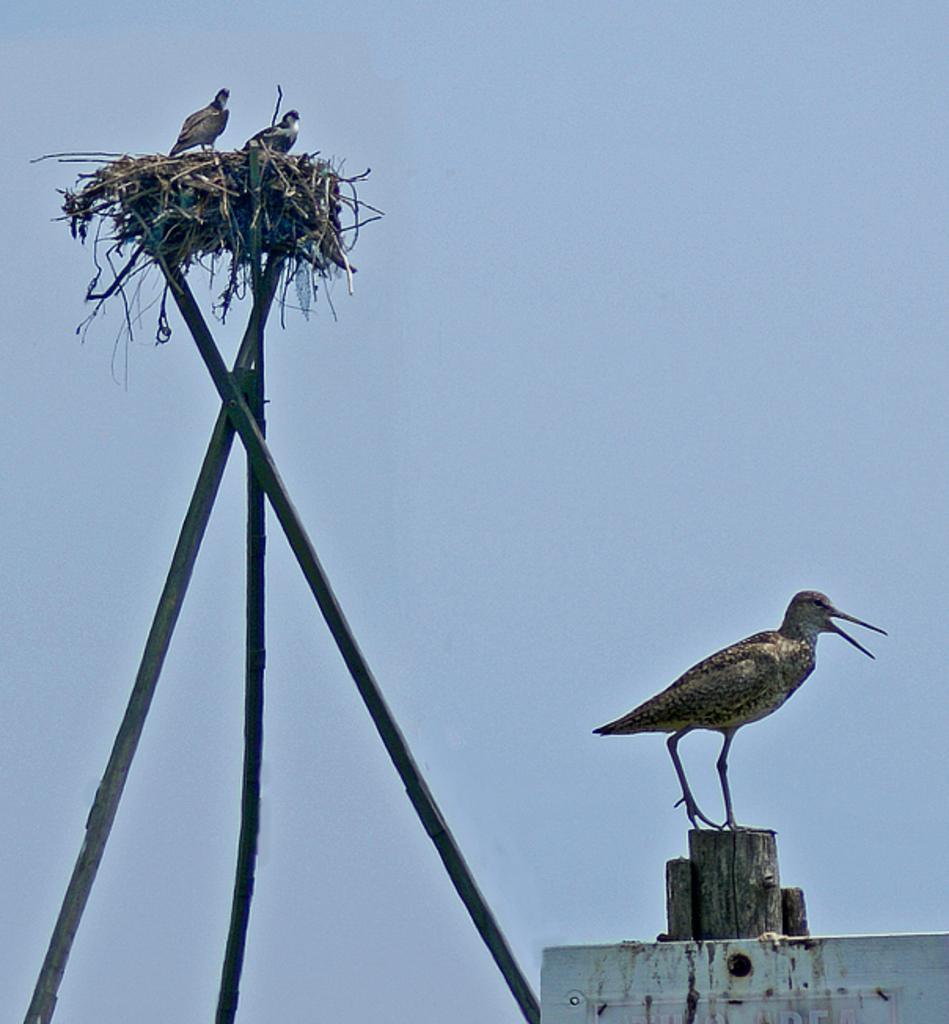Could you give a brief overview of what you see in this image? In this picture I can see couple of birds in the nest and I can see another bird on the wooden pole and I can see a blue sky. 